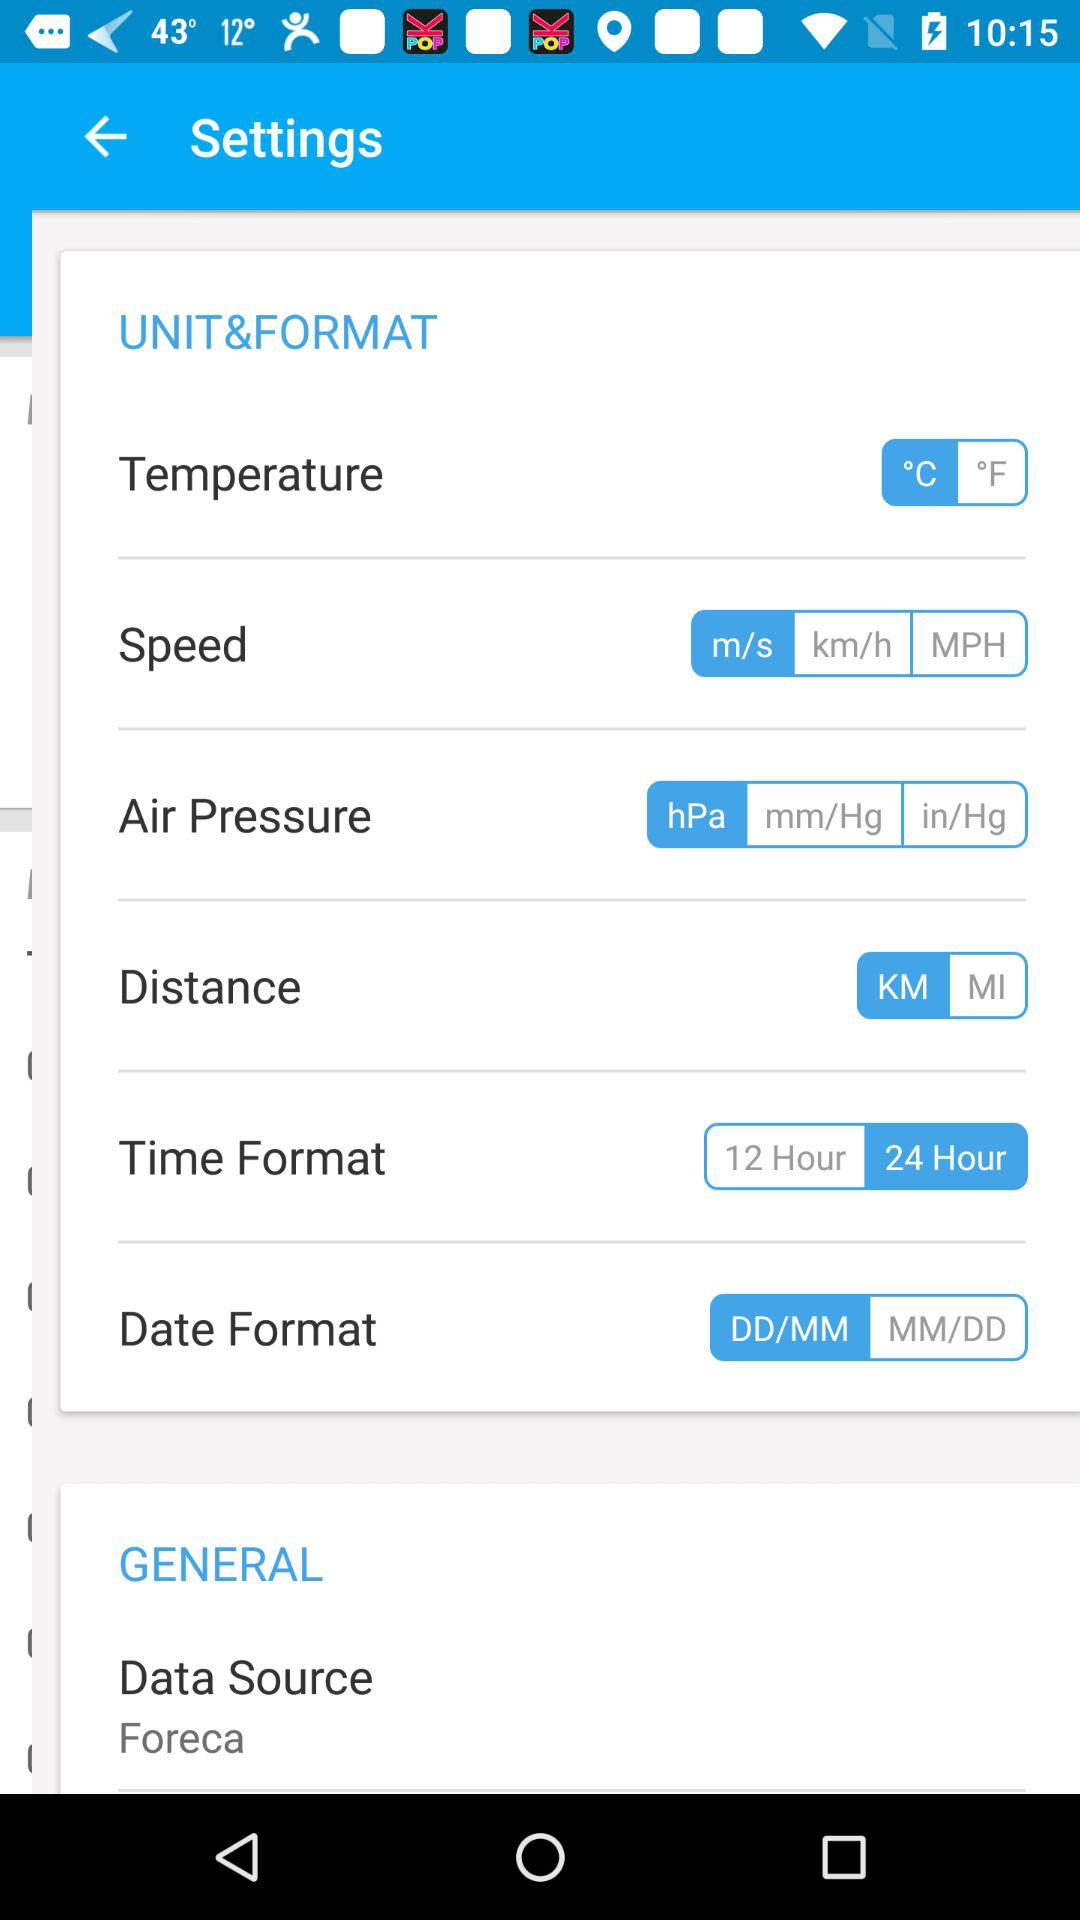What is the setting for "Data Source"? The setting is "Foreca". 